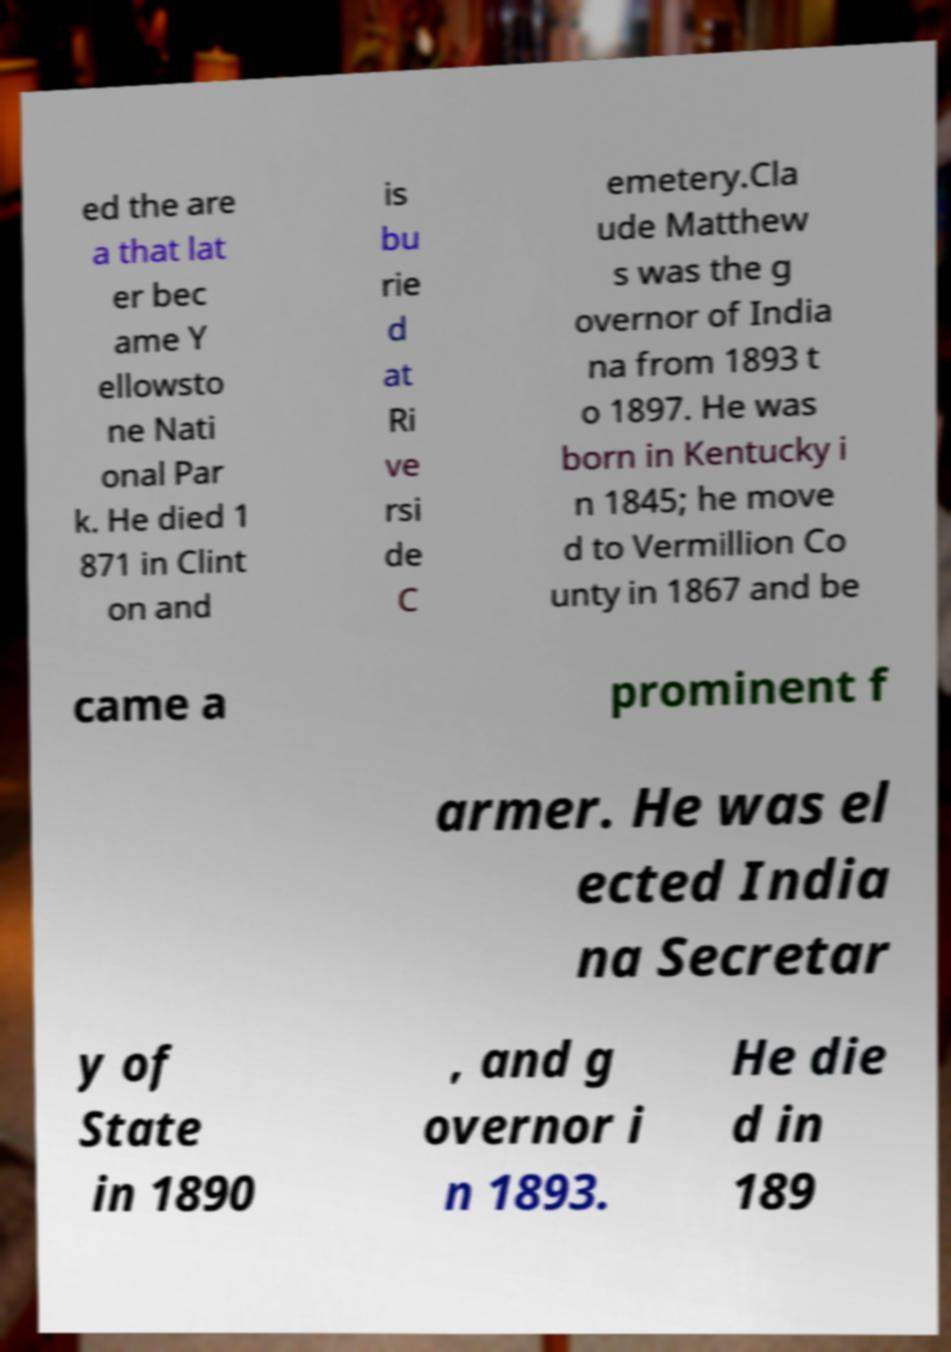Please read and relay the text visible in this image. What does it say? ed the are a that lat er bec ame Y ellowsto ne Nati onal Par k. He died 1 871 in Clint on and is bu rie d at Ri ve rsi de C emetery.Cla ude Matthew s was the g overnor of India na from 1893 t o 1897. He was born in Kentucky i n 1845; he move d to Vermillion Co unty in 1867 and be came a prominent f armer. He was el ected India na Secretar y of State in 1890 , and g overnor i n 1893. He die d in 189 